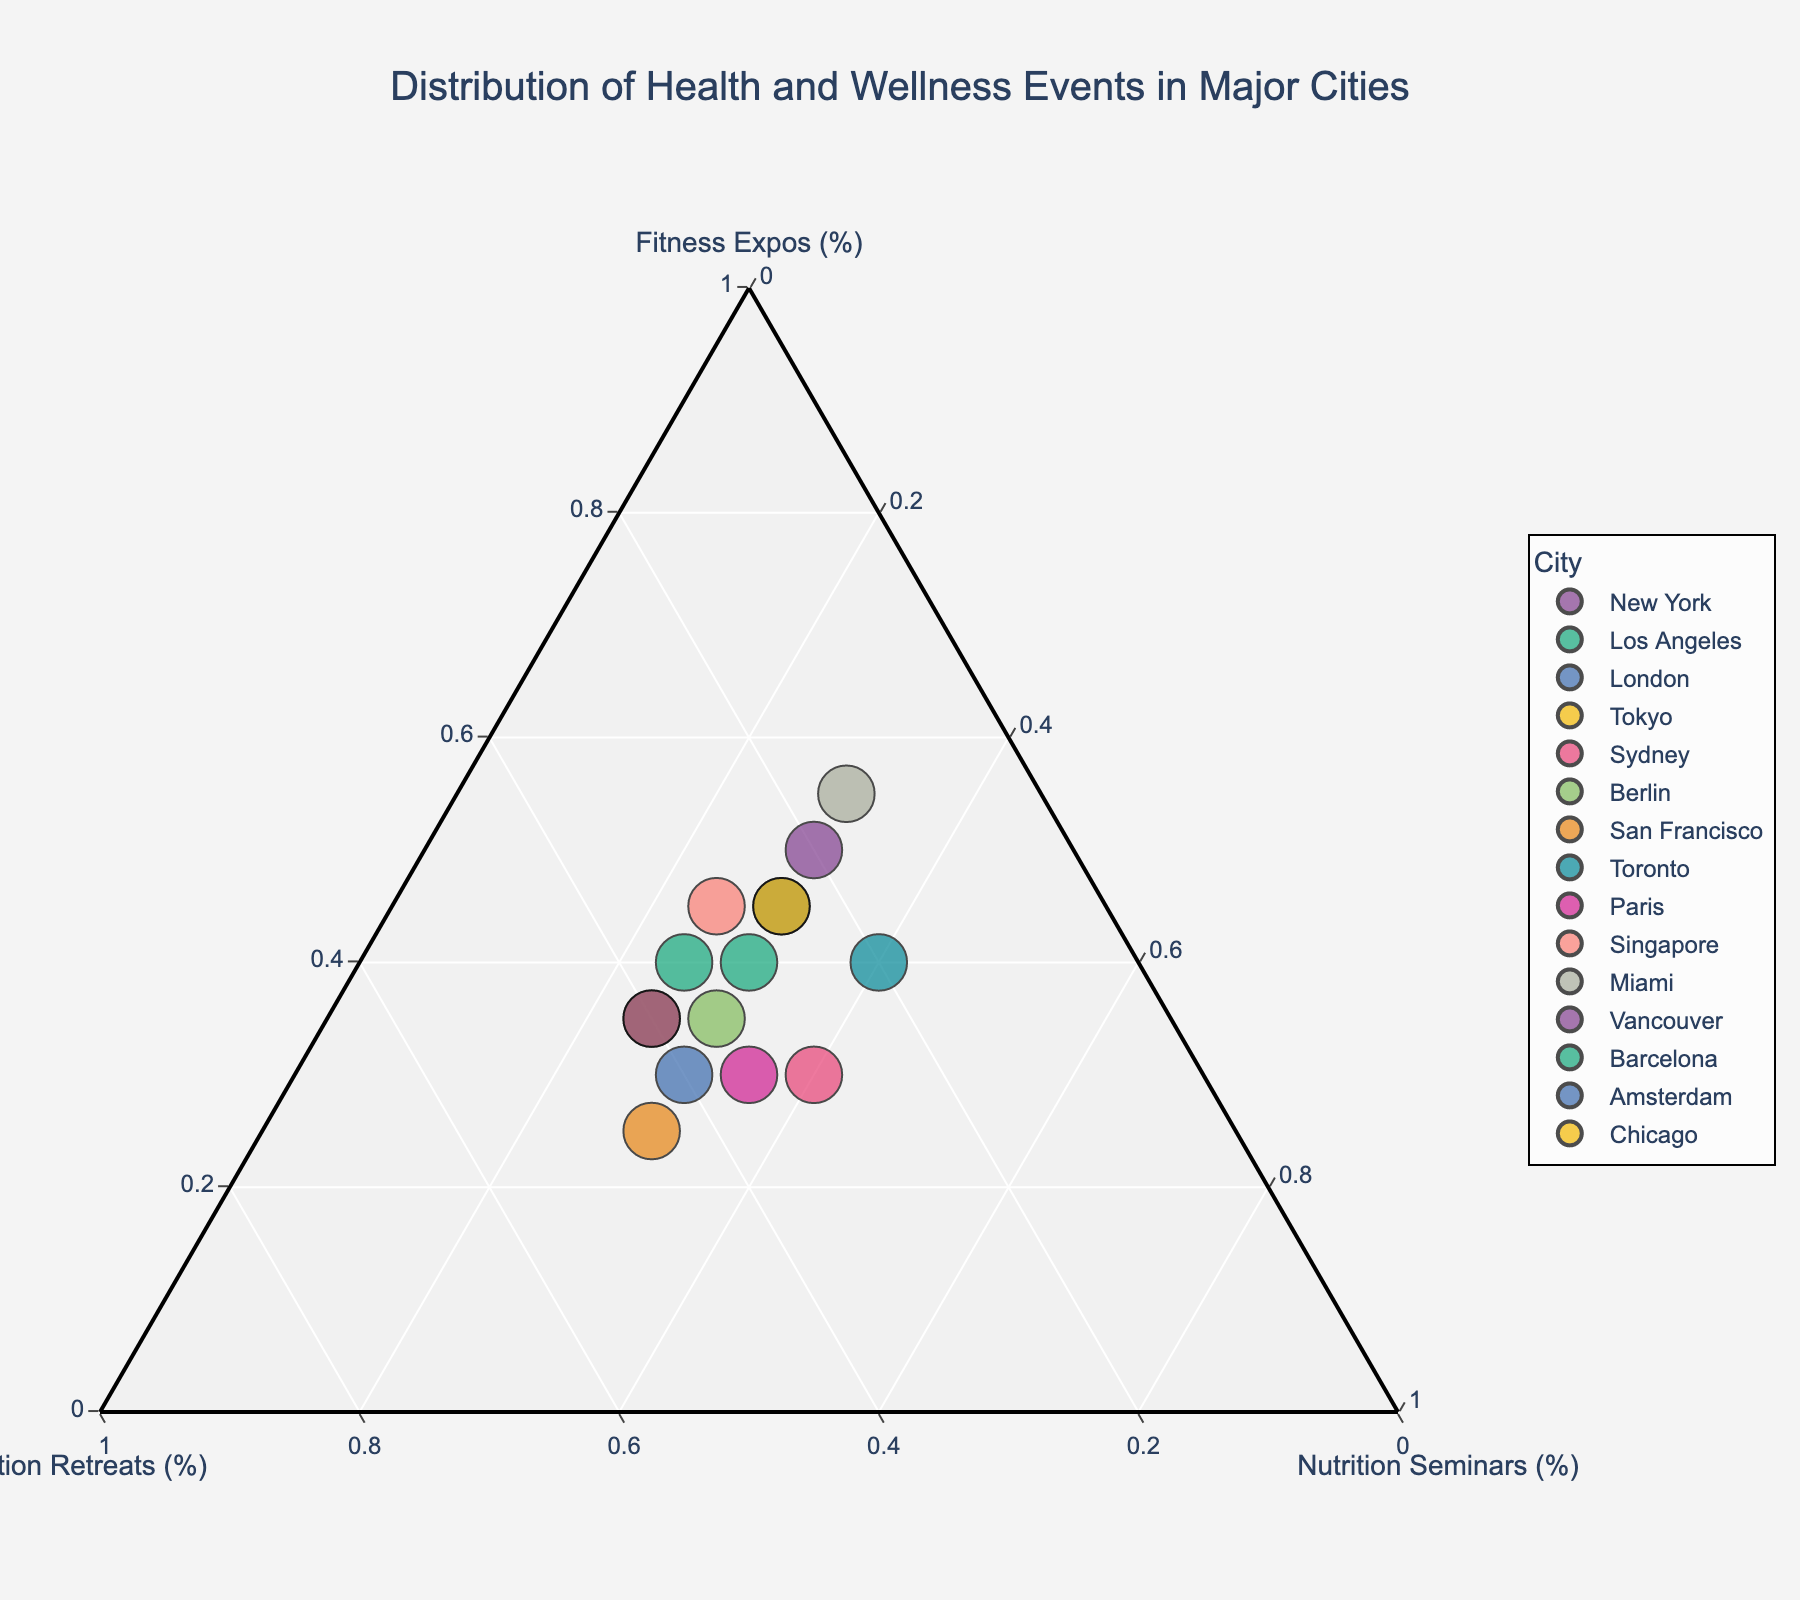What is the city with the highest percentage of Fitness Expos? The city with the highest percentage of Fitness Expos can be identified by locating the data point closest to the axis representing Fitness Expos. This point is Miami.
Answer: Miami Which city has an equal distribution of all three event types? An equal distribution of all three event types would place the city around the center of the ternary plot. Sydney is closest to this point.
Answer: Sydney Compare the percentage of Nutrition Seminars in New York and Los Angeles. Which one is higher? Locate New York and Los Angeles on the plot and compare their positions relative to the Nutrition Seminars axis. Los Angeles has a lower percentage compared to New York.
Answer: New York Which city has the highest percentage of Meditation Retreats? The city with the highest percentage of Meditation Retreats will be closest to the Meditation Retreats axis. This city is San Francisco.
Answer: San Francisco Identify the city with the highest percentage of Fitness Expos among Miami, Tokyo, and Berlin. Check the proximity of Miami, Tokyo, and Berlin to the Fitness Expos axis. Miami is the closest, indicating the highest percentage.
Answer: Miami What is the combined percentage of Meditation Retreats and Nutrition Seminars for Berlin? Add the percentage values for Meditation Retreats and Nutrition Seminars for Berlin by locating its respective point on the plot. Berlin has 35% Meditation Retreats and 30% Nutrition Seminars, so 35 + 30 = 65%.
Answer: 65% Which city has a higher percentage of Meditation Retreats, Tokyo or Vancouver? Compare the positions of Tokyo and Vancouver relative to the Meditation Retreats axis. Tokyo has a higher percentage of Meditation Retreats.
Answer: Tokyo In terms of Nutrition Seminars, which city has a higher percentage, Barcelona or Toronto? Compare Barcelona and Toronto based on their positions relative to the Nutrion Seminars axis. Both cities have equal positions indicating a tie with the same percentage.
Answer: Equal How do New York and Chicago compare in the distribution percentages of all three event types? Analyze the positions of New York and Chicago relative to all three axes (Fitness Expos, Meditation Retreats, and Nutrition Seminars). Both cities have similar distributions in terms of Fitness Expos and Nutrition Seminars percentages, but New York has a higher percentage of Meditation Retreats.
Answer: New York and Chicago are similar Which city has an event distribution closest to that of Sydney? Identify the city whose position closely aligns with Sydney's on the plot, meaning similar percentages of all three event types. Berlin is the closest to Sydney.
Answer: Berlin 